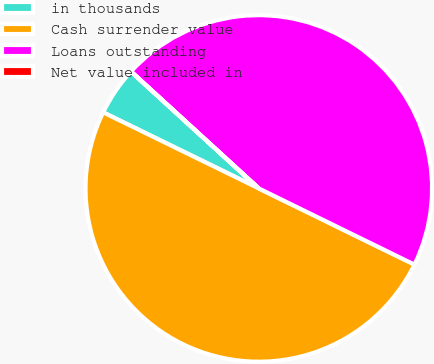Convert chart to OTSL. <chart><loc_0><loc_0><loc_500><loc_500><pie_chart><fcel>in thousands<fcel>Cash surrender value<fcel>Loans outstanding<fcel>Net value included in<nl><fcel>4.55%<fcel>49.99%<fcel>45.45%<fcel>0.01%<nl></chart> 